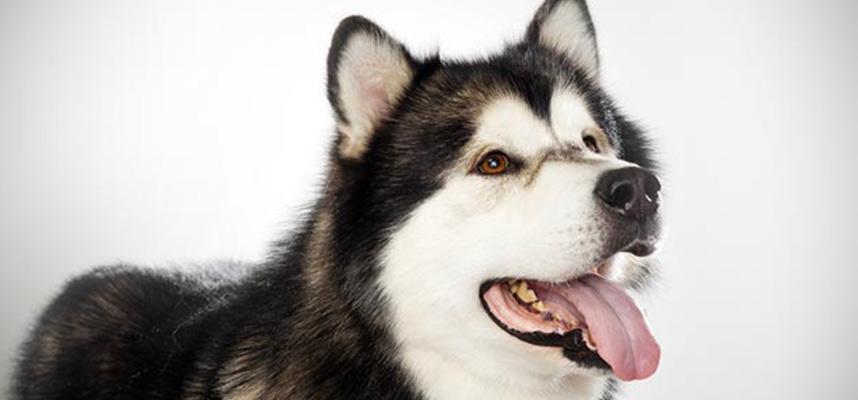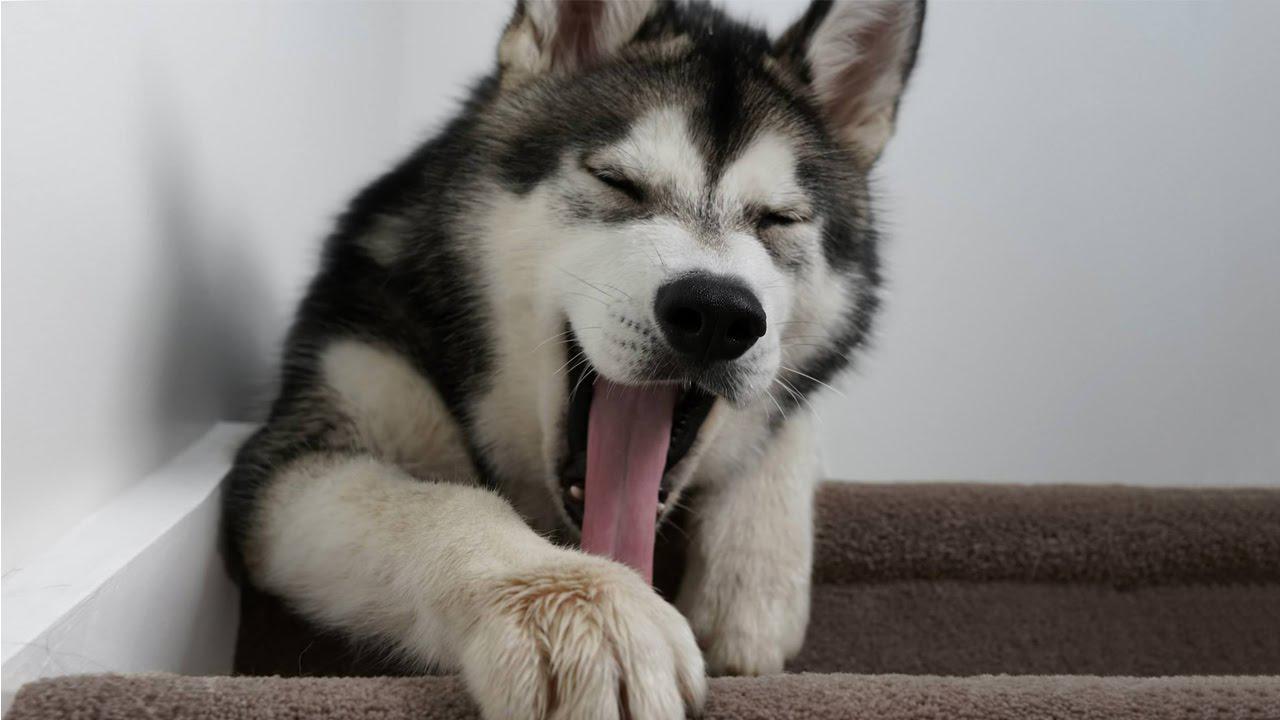The first image is the image on the left, the second image is the image on the right. For the images shown, is this caption "Each image features only one dog, and the dog on the left has an open mouth, while the dog on the right has a closed mouth." true? Answer yes or no. No. The first image is the image on the left, the second image is the image on the right. Evaluate the accuracy of this statement regarding the images: "In the image to the right you can see the dog's tongue.". Is it true? Answer yes or no. Yes. 